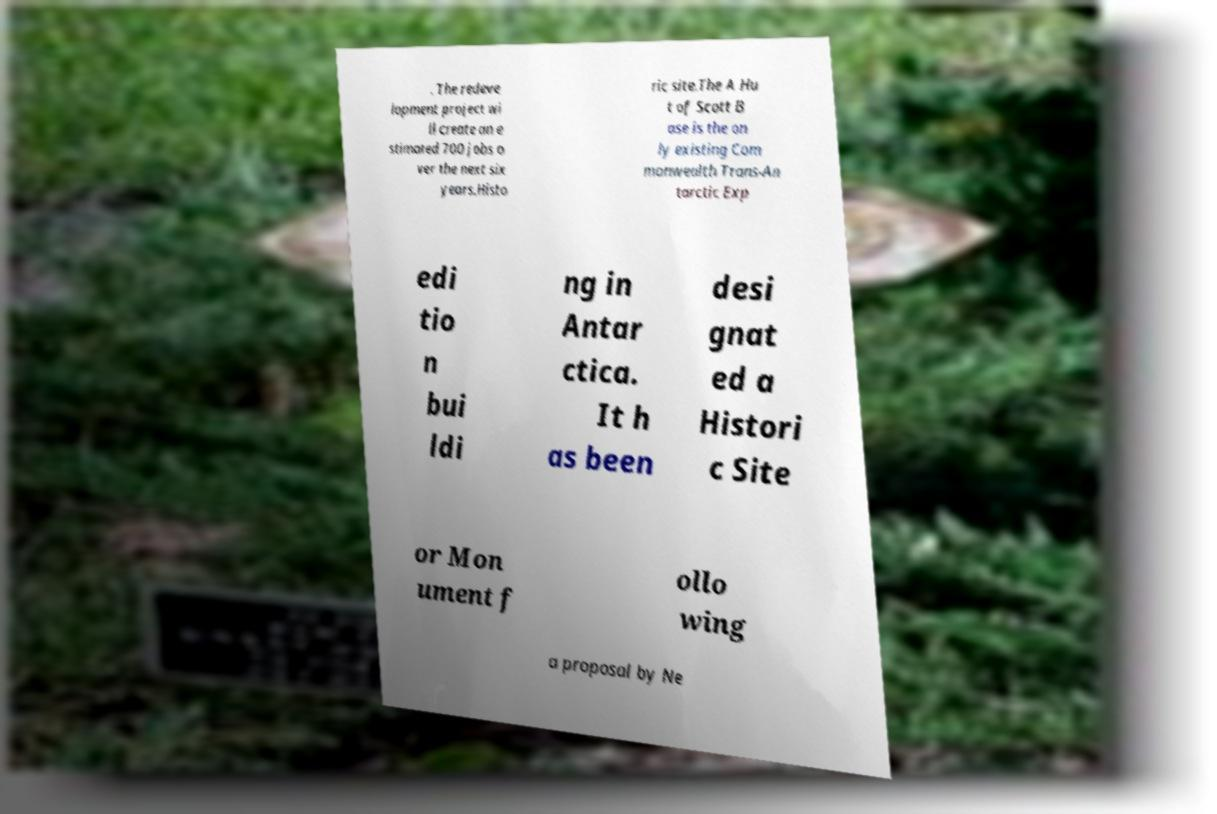Can you accurately transcribe the text from the provided image for me? . The redeve lopment project wi ll create an e stimated 700 jobs o ver the next six years.Histo ric site.The A Hu t of Scott B ase is the on ly existing Com monwealth Trans-An tarctic Exp edi tio n bui ldi ng in Antar ctica. It h as been desi gnat ed a Histori c Site or Mon ument f ollo wing a proposal by Ne 